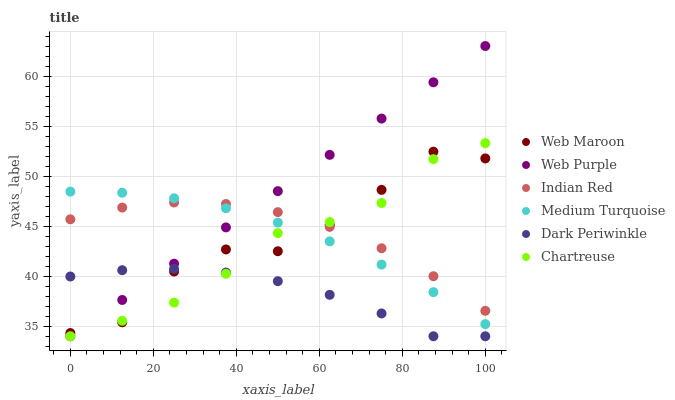Does Dark Periwinkle have the minimum area under the curve?
Answer yes or no. Yes. Does Web Purple have the maximum area under the curve?
Answer yes or no. Yes. Does Web Maroon have the minimum area under the curve?
Answer yes or no. No. Does Web Maroon have the maximum area under the curve?
Answer yes or no. No. Is Web Purple the smoothest?
Answer yes or no. Yes. Is Web Maroon the roughest?
Answer yes or no. Yes. Is Web Maroon the smoothest?
Answer yes or no. No. Is Web Purple the roughest?
Answer yes or no. No. Does Web Purple have the lowest value?
Answer yes or no. Yes. Does Web Maroon have the lowest value?
Answer yes or no. No. Does Web Purple have the highest value?
Answer yes or no. Yes. Does Web Maroon have the highest value?
Answer yes or no. No. Is Dark Periwinkle less than Indian Red?
Answer yes or no. Yes. Is Indian Red greater than Dark Periwinkle?
Answer yes or no. Yes. Does Web Purple intersect Web Maroon?
Answer yes or no. Yes. Is Web Purple less than Web Maroon?
Answer yes or no. No. Is Web Purple greater than Web Maroon?
Answer yes or no. No. Does Dark Periwinkle intersect Indian Red?
Answer yes or no. No. 